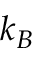<formula> <loc_0><loc_0><loc_500><loc_500>k _ { B }</formula> 